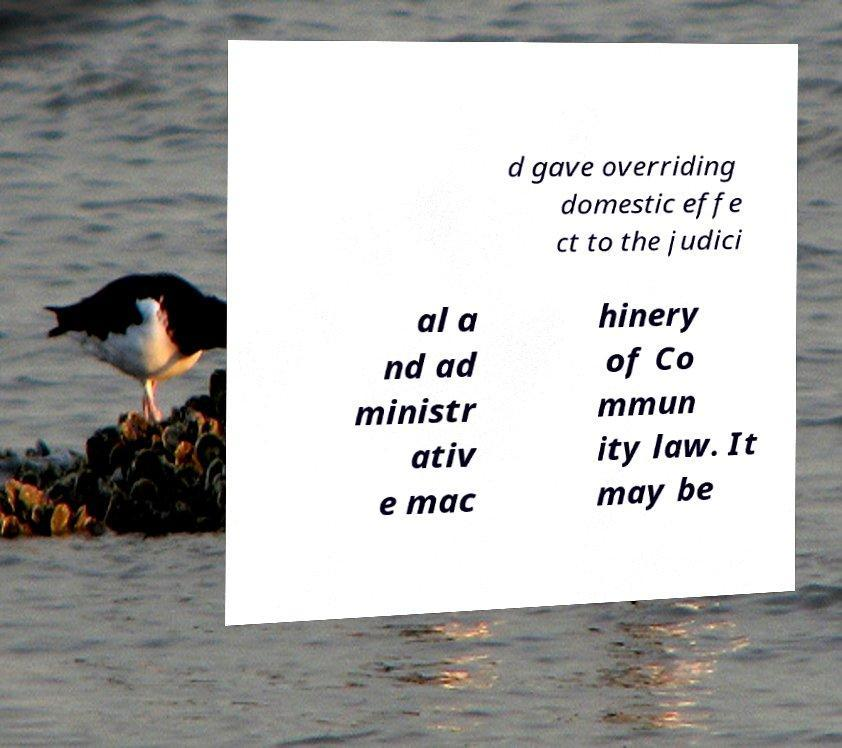Please read and relay the text visible in this image. What does it say? d gave overriding domestic effe ct to the judici al a nd ad ministr ativ e mac hinery of Co mmun ity law. It may be 